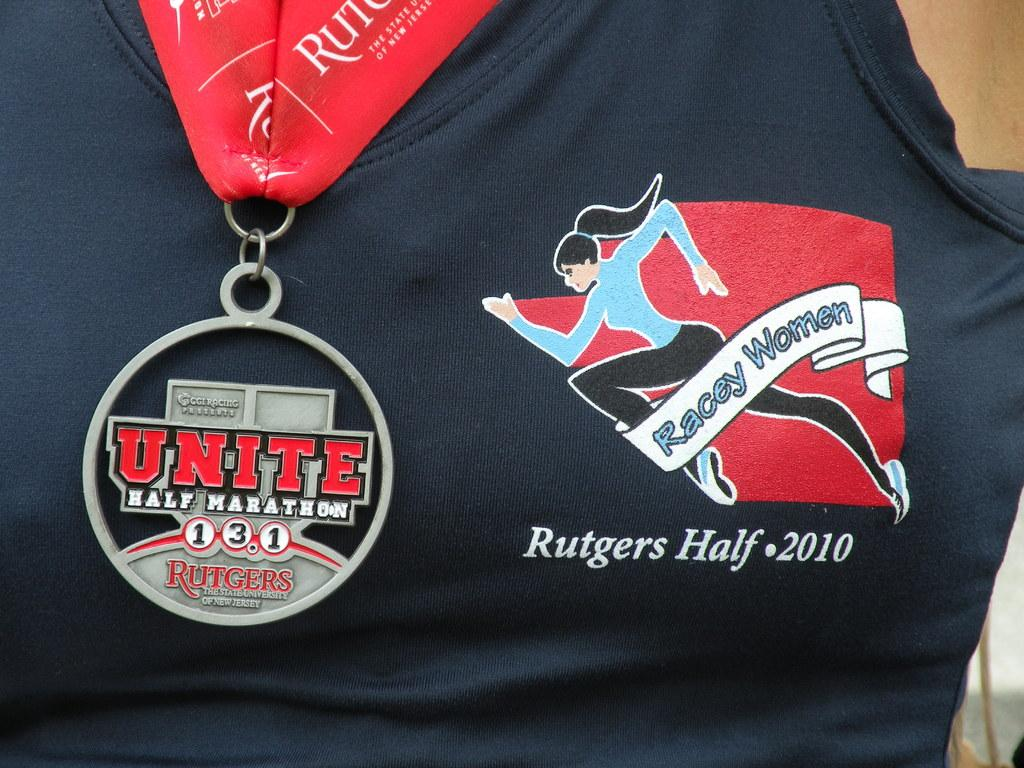<image>
Share a concise interpretation of the image provided. A Unite half marathon medal is hanging off a woman's neck. 